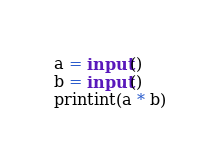Convert code to text. <code><loc_0><loc_0><loc_500><loc_500><_Python_>a = input()
b = input()
printint(a * b)</code> 